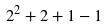Convert formula to latex. <formula><loc_0><loc_0><loc_500><loc_500>2 ^ { 2 } + 2 + 1 - 1</formula> 